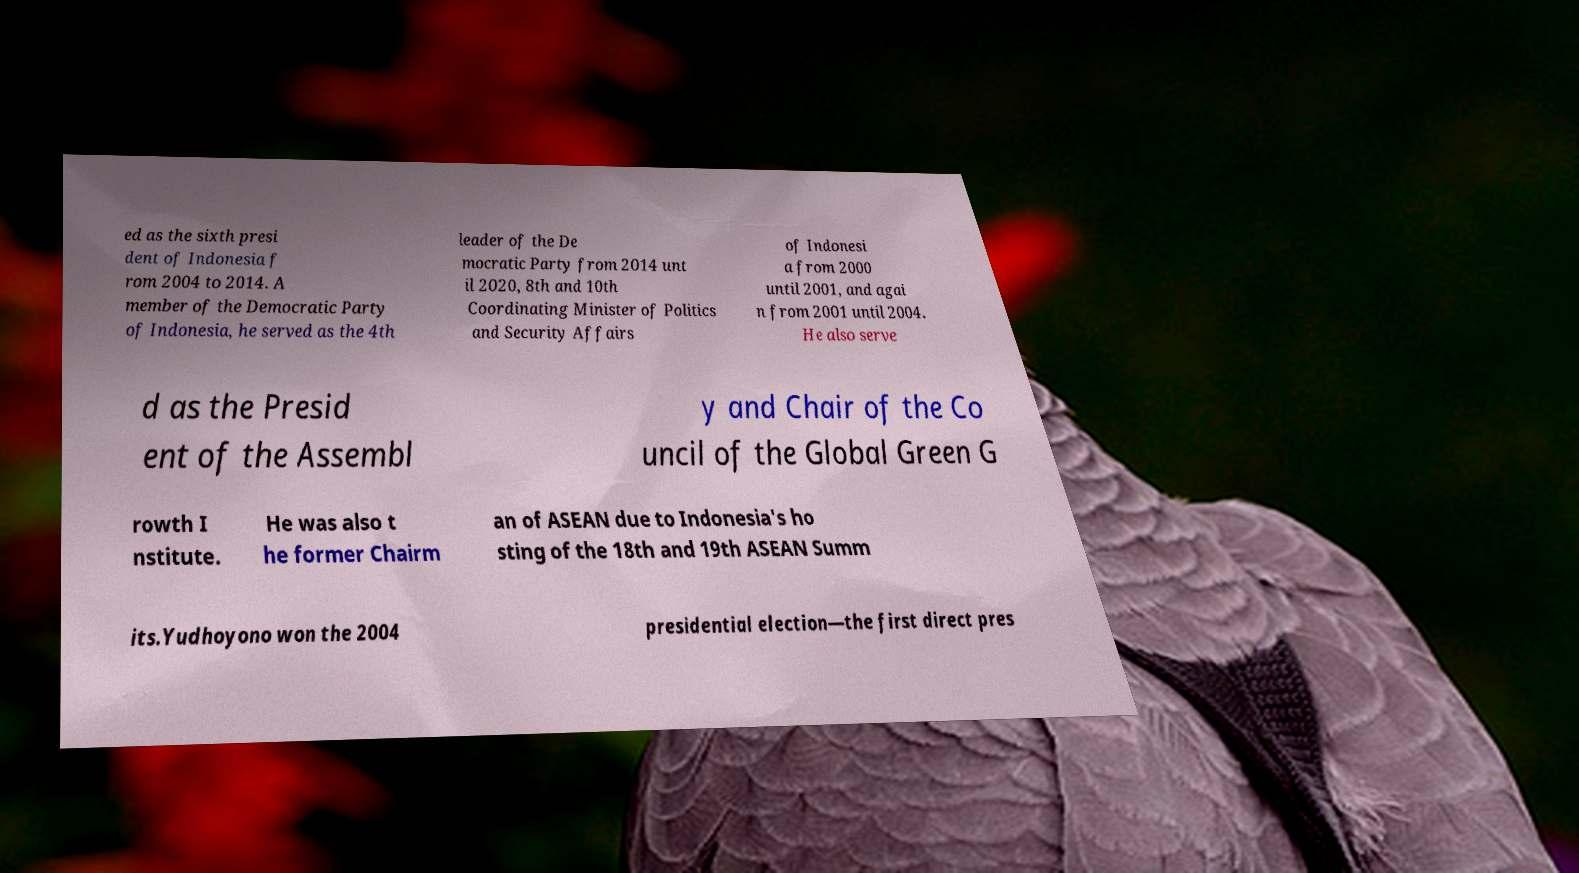Please read and relay the text visible in this image. What does it say? ed as the sixth presi dent of Indonesia f rom 2004 to 2014. A member of the Democratic Party of Indonesia, he served as the 4th leader of the De mocratic Party from 2014 unt il 2020, 8th and 10th Coordinating Minister of Politics and Security Affairs of Indonesi a from 2000 until 2001, and agai n from 2001 until 2004. He also serve d as the Presid ent of the Assembl y and Chair of the Co uncil of the Global Green G rowth I nstitute. He was also t he former Chairm an of ASEAN due to Indonesia's ho sting of the 18th and 19th ASEAN Summ its.Yudhoyono won the 2004 presidential election—the first direct pres 